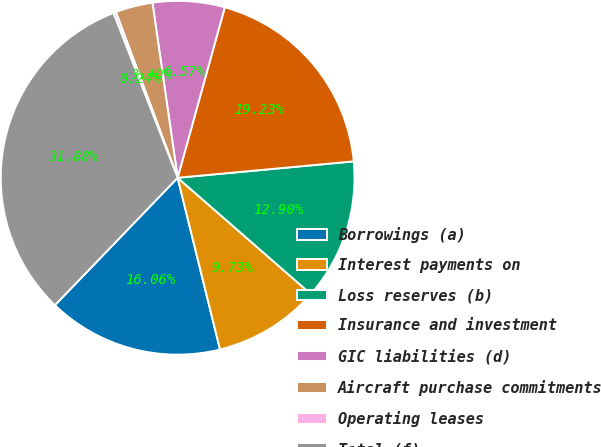<chart> <loc_0><loc_0><loc_500><loc_500><pie_chart><fcel>Borrowings (a)<fcel>Interest payments on<fcel>Loss reserves (b)<fcel>Insurance and investment<fcel>GIC liabilities (d)<fcel>Aircraft purchase commitments<fcel>Operating leases<fcel>Total (f)<nl><fcel>16.06%<fcel>9.73%<fcel>12.9%<fcel>19.23%<fcel>6.57%<fcel>3.4%<fcel>0.24%<fcel>31.89%<nl></chart> 